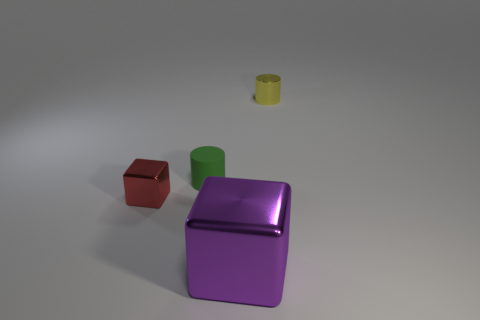What is the color of the tiny thing on the right side of the large purple cube right of the small block in front of the tiny green object?
Your answer should be very brief. Yellow. How many other objects are there of the same shape as the small yellow thing?
Your response must be concise. 1. Is the matte cylinder the same color as the large thing?
Your answer should be compact. No. What number of things are small purple objects or red objects left of the green matte cylinder?
Ensure brevity in your answer.  1. Is there a red metal thing that has the same size as the rubber cylinder?
Provide a short and direct response. Yes. Is the small block made of the same material as the big cube?
Provide a short and direct response. Yes. What number of things are either red metal things or small brown rubber cylinders?
Make the answer very short. 1. What is the size of the red object?
Keep it short and to the point. Small. Are there fewer large green balls than small rubber cylinders?
Offer a very short reply. Yes. How many other small cubes have the same color as the tiny block?
Keep it short and to the point. 0. 